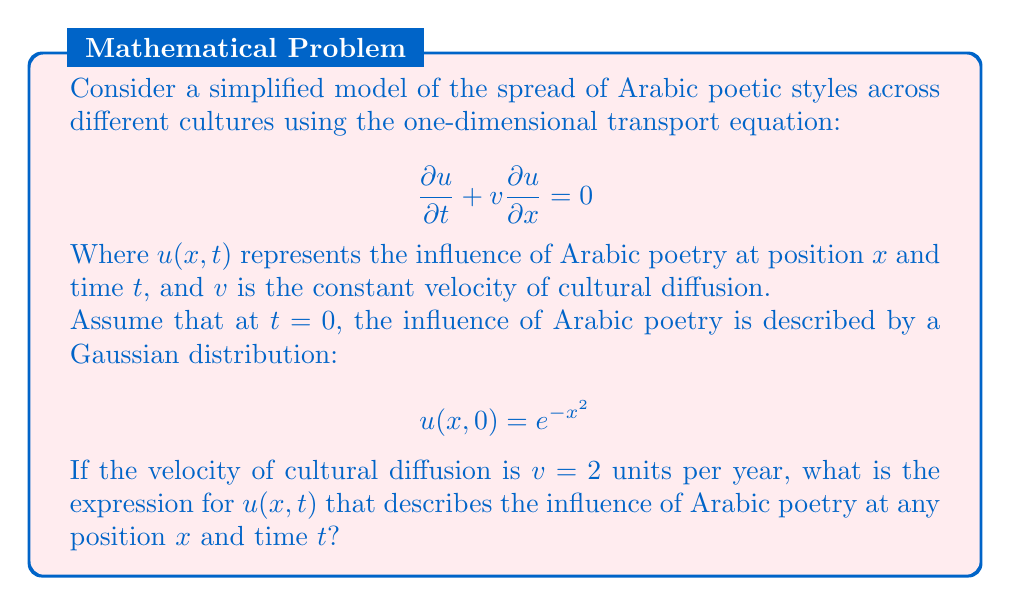Teach me how to tackle this problem. To solve this problem, we'll use the method of characteristics for the transport equation.

1) The general solution to the transport equation is of the form:
   $$u(x,t) = f(x - vt)$$
   where $f$ is a function determined by the initial conditions.

2) Given the initial condition $u(x,0) = e^{-x^2}$, we can deduce that:
   $$f(x) = e^{-x^2}$$

3) Substituting this into the general solution and using $v=2$:
   $$u(x,t) = f(x - 2t) = e^{-(x-2t)^2}$$

4) This expression represents a Gaussian curve moving to the right at a speed of 2 units per year, maintaining its shape but shifting its position.

5) We can verify this solution by substituting it back into the original equation:

   $$\frac{\partial u}{\partial t} = -2(x-2t)e^{-(x-2t)^2} \cdot (-2) = 4(x-2t)e^{-(x-2t)^2}$$
   
   $$\frac{\partial u}{\partial x} = -2(x-2t)e^{-(x-2t)^2}$$
   
   $$\frac{\partial u}{\partial t} + 2\frac{\partial u}{\partial x} = 4(x-2t)e^{-(x-2t)^2} - 4(x-2t)e^{-(x-2t)^2} = 0$$

Thus, our solution satisfies the transport equation.
Answer: $$u(x,t) = e^{-(x-2t)^2}$$ 